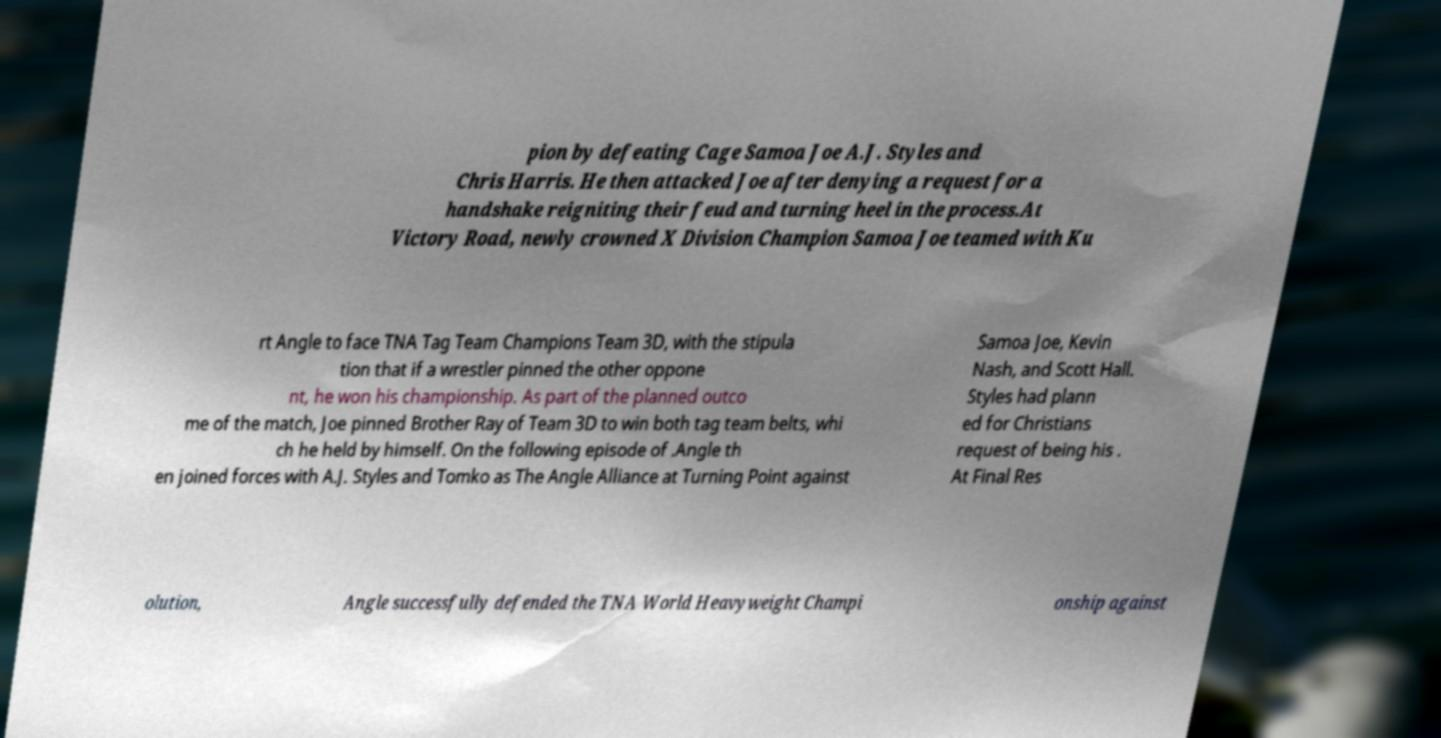Please read and relay the text visible in this image. What does it say? pion by defeating Cage Samoa Joe A.J. Styles and Chris Harris. He then attacked Joe after denying a request for a handshake reigniting their feud and turning heel in the process.At Victory Road, newly crowned X Division Champion Samoa Joe teamed with Ku rt Angle to face TNA Tag Team Champions Team 3D, with the stipula tion that if a wrestler pinned the other oppone nt, he won his championship. As part of the planned outco me of the match, Joe pinned Brother Ray of Team 3D to win both tag team belts, whi ch he held by himself. On the following episode of .Angle th en joined forces with A.J. Styles and Tomko as The Angle Alliance at Turning Point against Samoa Joe, Kevin Nash, and Scott Hall. Styles had plann ed for Christians request of being his . At Final Res olution, Angle successfully defended the TNA World Heavyweight Champi onship against 